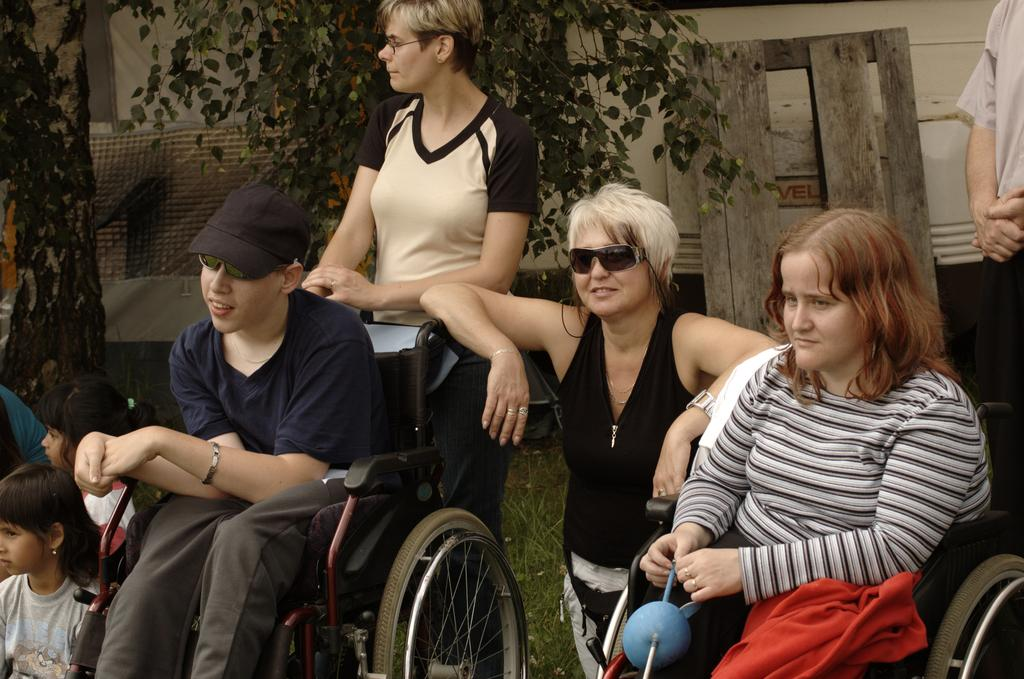Who is in the foreground of the picture? There are people and kids in the foreground of the picture. What are the people using in the foreground of the picture? Wheelchairs are present in the foreground of the picture. What type of terrain is visible in the foreground of the picture? Grass is visible in the foreground of the picture. What can be seen in the background of the picture? There are trees, wooden objects, a vehicle, and other objects in the background of the picture. What song is being sung by the kids in the picture? There is no indication in the image that the kids are singing a song, so it cannot be determined from the picture. What type of string is being used by the people in the wheelchairs? There is no string visible in the image, and the people in the wheelchairs are not shown using any string. 